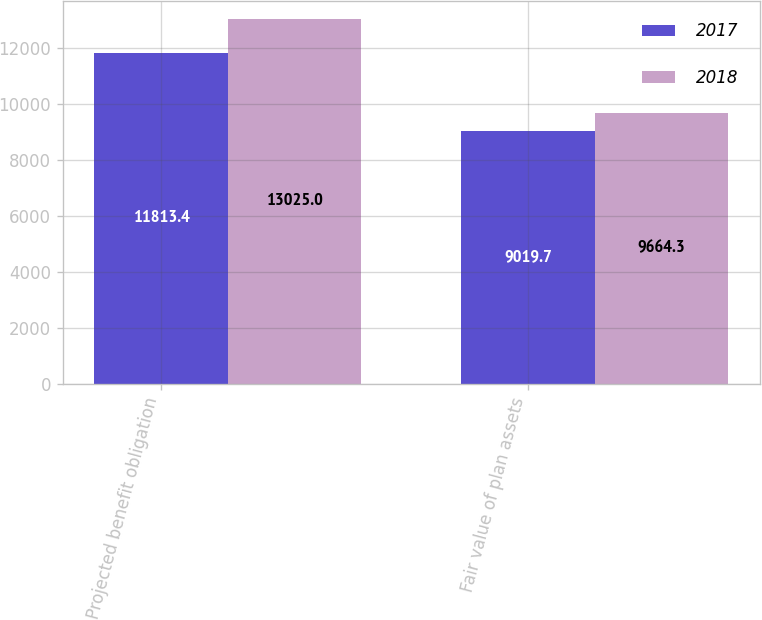<chart> <loc_0><loc_0><loc_500><loc_500><stacked_bar_chart><ecel><fcel>Projected benefit obligation<fcel>Fair value of plan assets<nl><fcel>2017<fcel>11813.4<fcel>9019.7<nl><fcel>2018<fcel>13025<fcel>9664.3<nl></chart> 